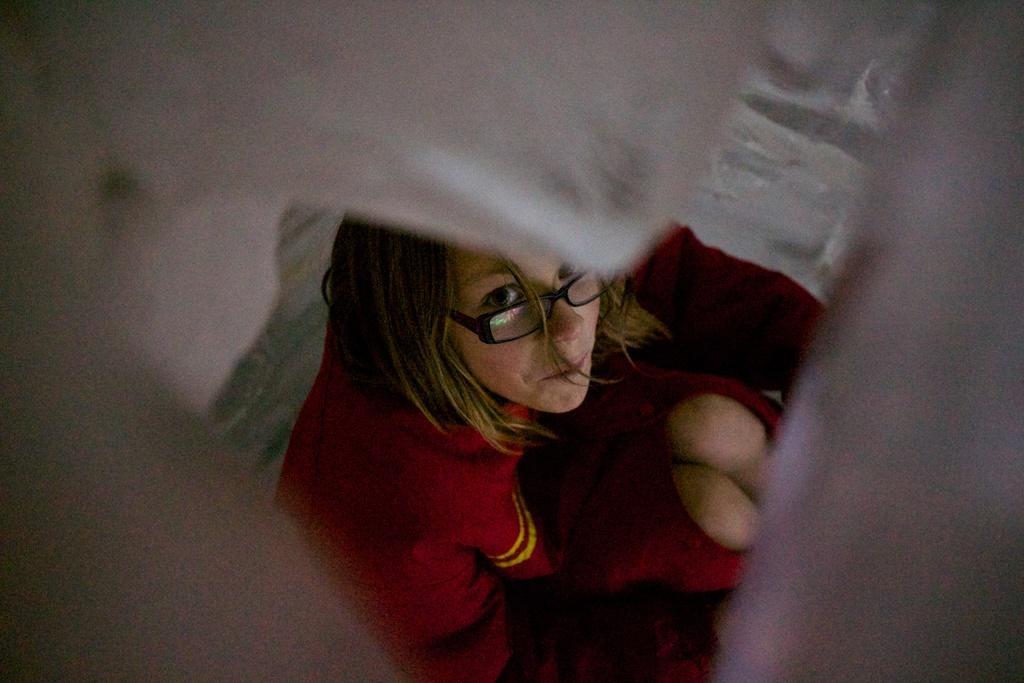Who is the main subject in the image? There is a woman in the image. What is the woman wearing? The woman is wearing a red dress. Where is the woman located in the image? The woman is in the center of the image. What can be seen on the edges of the image? There is an object on the edges of the image. How does the woman control the bikes in the image? There are no bikes present in the image, so the woman cannot control any bikes. What type of honey is being used by the woman in the image? There is no honey present in the image, so it cannot be determined what type of honey the woman might be using. 